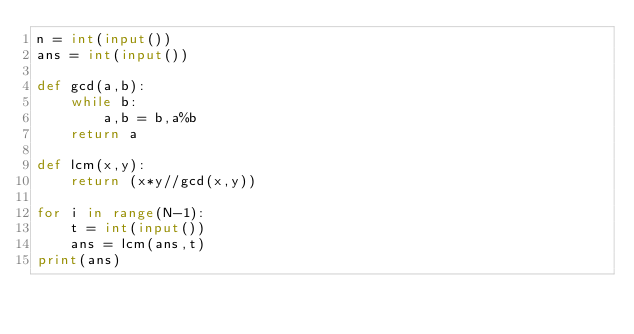<code> <loc_0><loc_0><loc_500><loc_500><_Python_>n = int(input())
ans = int(input())
 
def gcd(a,b):
    while b:
        a,b = b,a%b
    return a
 
def lcm(x,y):
    return (x*y//gcd(x,y))
 
for i in range(N-1):
    t = int(input())
    ans = lcm(ans,t)
print(ans)</code> 